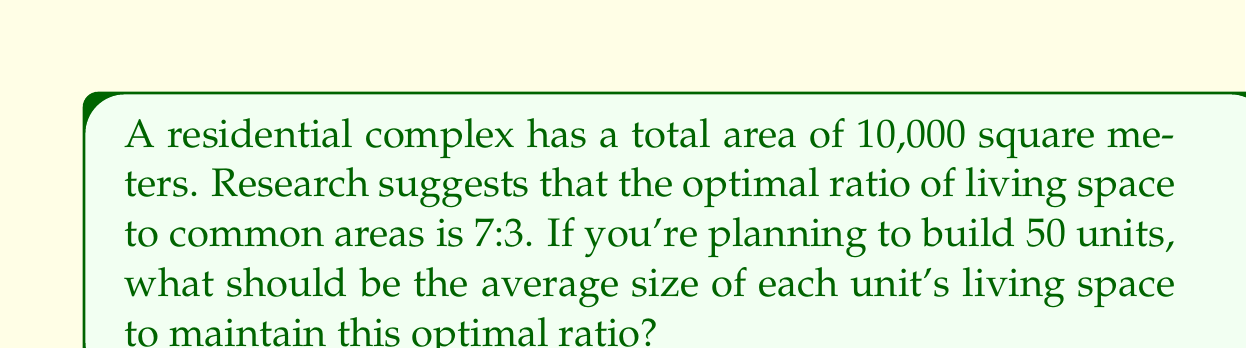Can you answer this question? Let's approach this step-by-step:

1) First, let's calculate the area allocated for living space and common areas based on the optimal ratio:

   Living space: $\frac{7}{10} \times 10,000 = 7,000$ sq meters
   Common areas: $\frac{3}{10} \times 10,000 = 3,000$ sq meters

2) We're interested in the living space, which is 7,000 sq meters.

3) This living space needs to be divided among 50 units.

4) To find the average size of each unit's living space, we divide the total living space by the number of units:

   $$\text{Average unit size} = \frac{\text{Total living space}}{\text{Number of units}} = \frac{7,000}{50} = 140$$ sq meters

Therefore, to maintain the optimal 7:3 ratio of living space to common areas in this 10,000 sq meter complex with 50 units, each unit should have an average living space of 140 sq meters.
Answer: 140 sq meters 